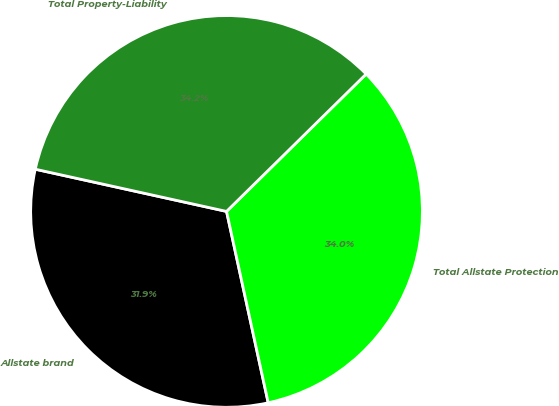<chart> <loc_0><loc_0><loc_500><loc_500><pie_chart><fcel>Allstate brand<fcel>Total Allstate Protection<fcel>Total Property-Liability<nl><fcel>31.87%<fcel>33.96%<fcel>34.17%<nl></chart> 